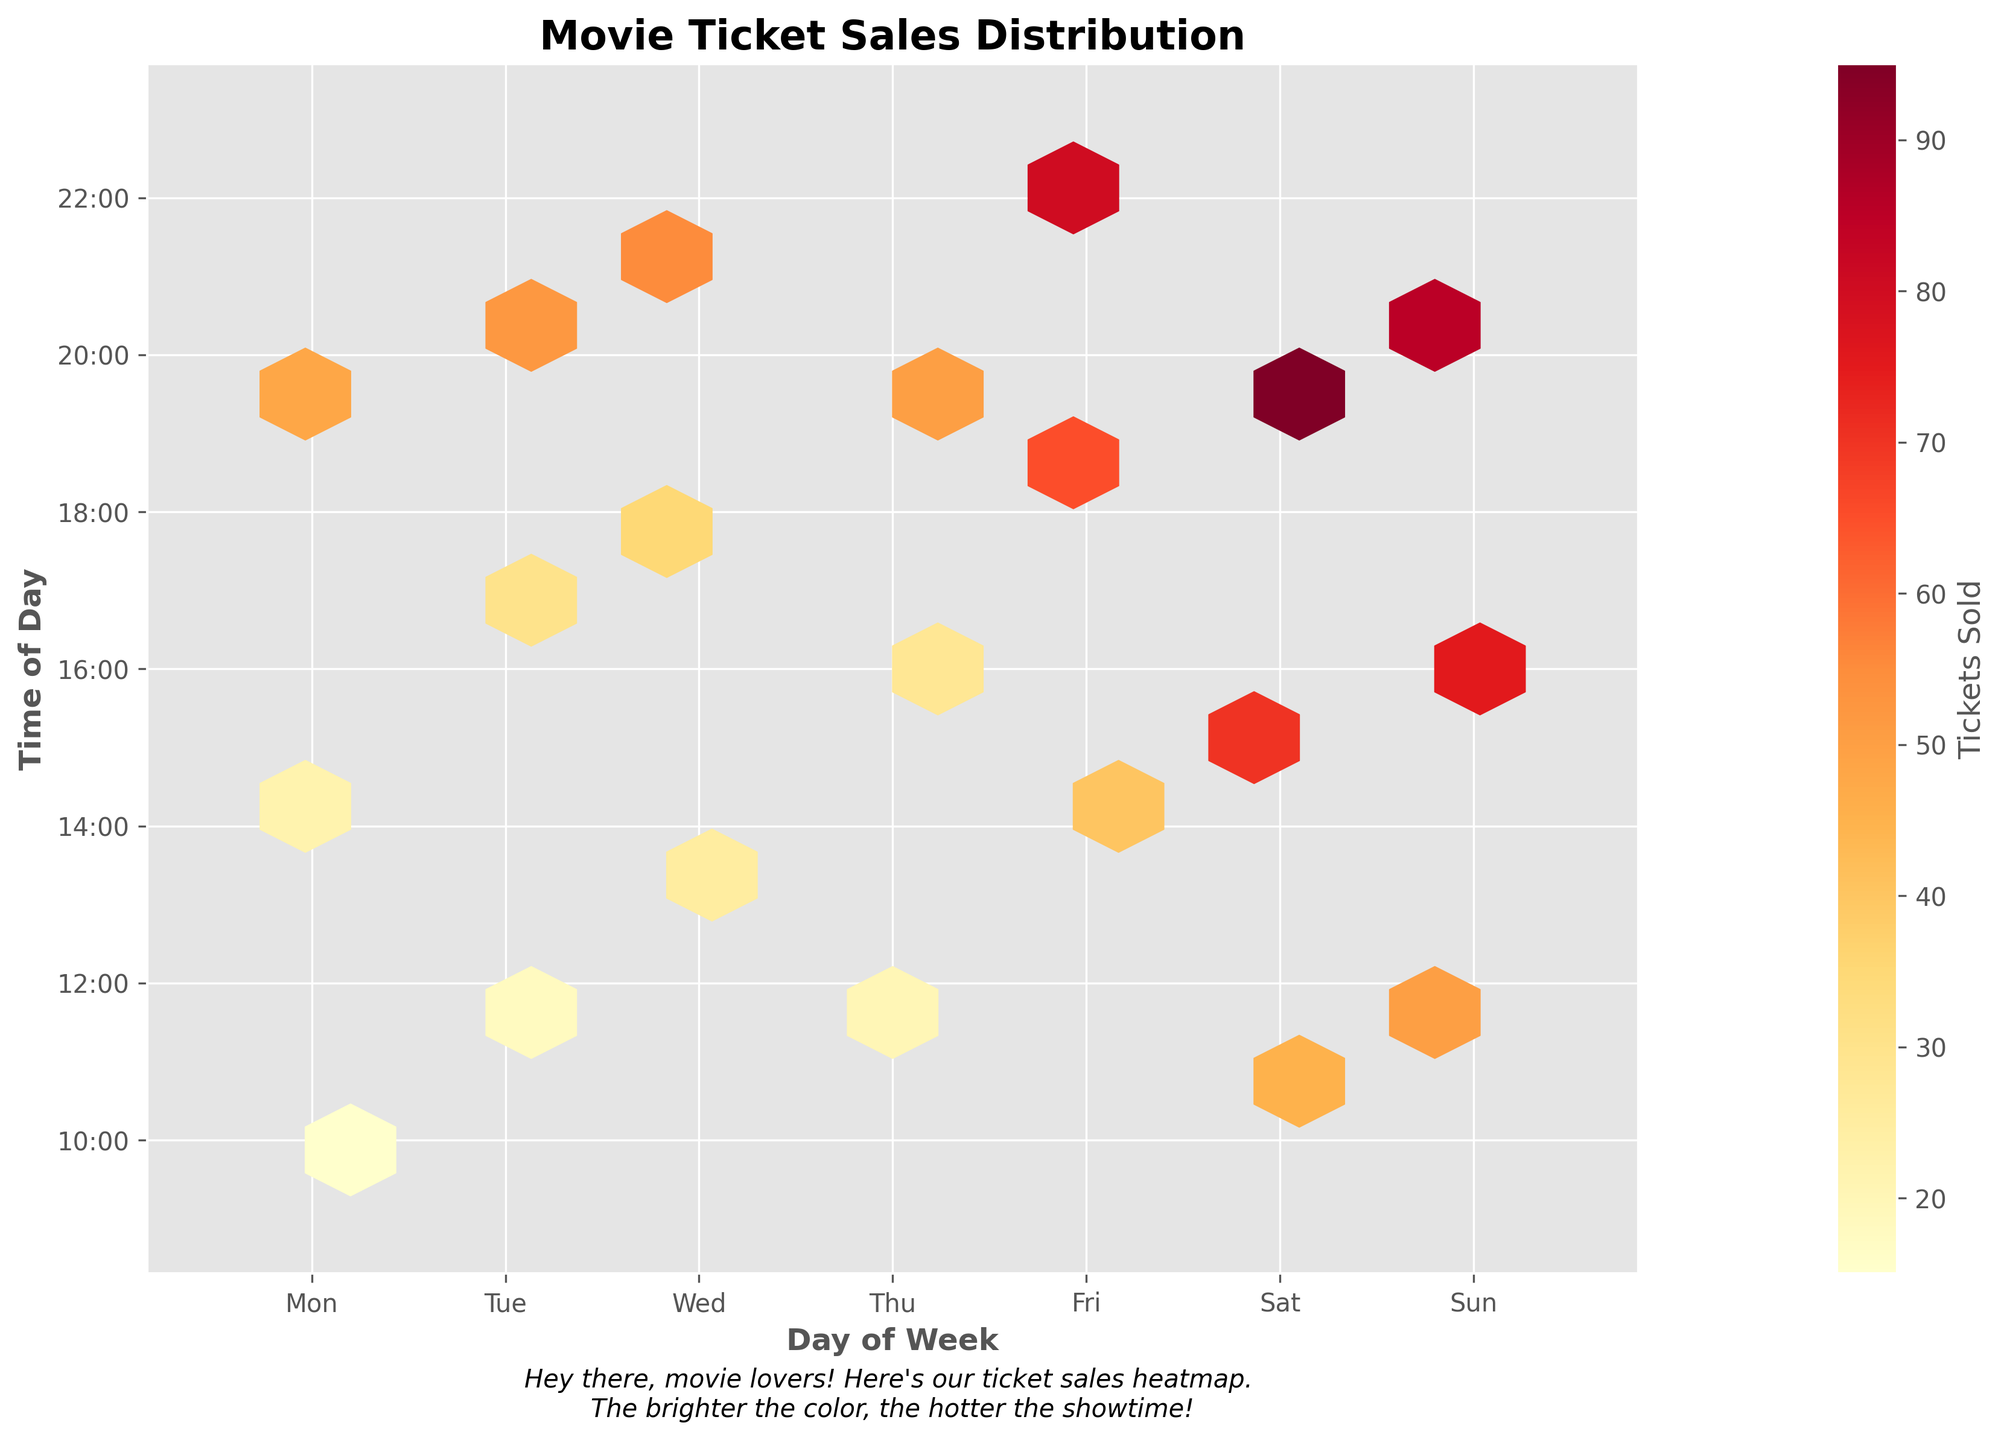What is the title of the figure? The title is usually placed at the top of the figure. In this case, it indicates a brief description of the data shown in the plot.
Answer: Movie Ticket Sales Distribution On which days does the hexbin plot show the highest ticket sales concentration? By looking at the color intensity represented on the hexbin plot, the days with the brightest colors indicate the highest ticket sales concentration.
Answer: Saturday and Sunday During what time frame do we see the highest ticket sales on Saturday? Observing the color intensity on Saturday using the time axis, the brightest hexbin shows around what time the ticket sales are highest.
Answer: 19:00-20:00 Which day of the week has the least concentration of ticket sales? By examining the hexbin plot, the day with the least bright or dense hexagons indicates the least concentration of ticket sales.
Answer: Monday What time of day generally shows the lowest ticket sales across all days of the week? Reviewing the hexbin plot, the areas with the least color intensity along the time axis show the periods with the least ticket sales.
Answer: 10:00-12:00 How does the ticket sales concentration between Friday at 20:00 compare to Sunday at 20:00? By directly comparing the color intensity of the hexbin at these two specific times, one can determine which period has more sales.
Answer: Sunday at 20:00 is higher What is the color of hexagons where around 50 tickets are sold? The colorbar indicates the range of colors corresponding to ticket sales; observe the color that corresponds to around 50 tickets sold.
Answer: Medium Orange Between which hours does the hexbin plot show a gradual increase in ticket sales on Wednesday? Examine the color transition on Wednesday from lighter to brighter hexagons along the time axis to understand the time period with a gradual increase in sales.
Answer: 13:00 to 21:00 On average, at what time on weekends do we see peak ticket sales? Both Saturday and Sunday should be reviewed to identify the peak sale times, then calculate the average of these times for an overall weekend peak time.
Answer: 18:00-20:00 